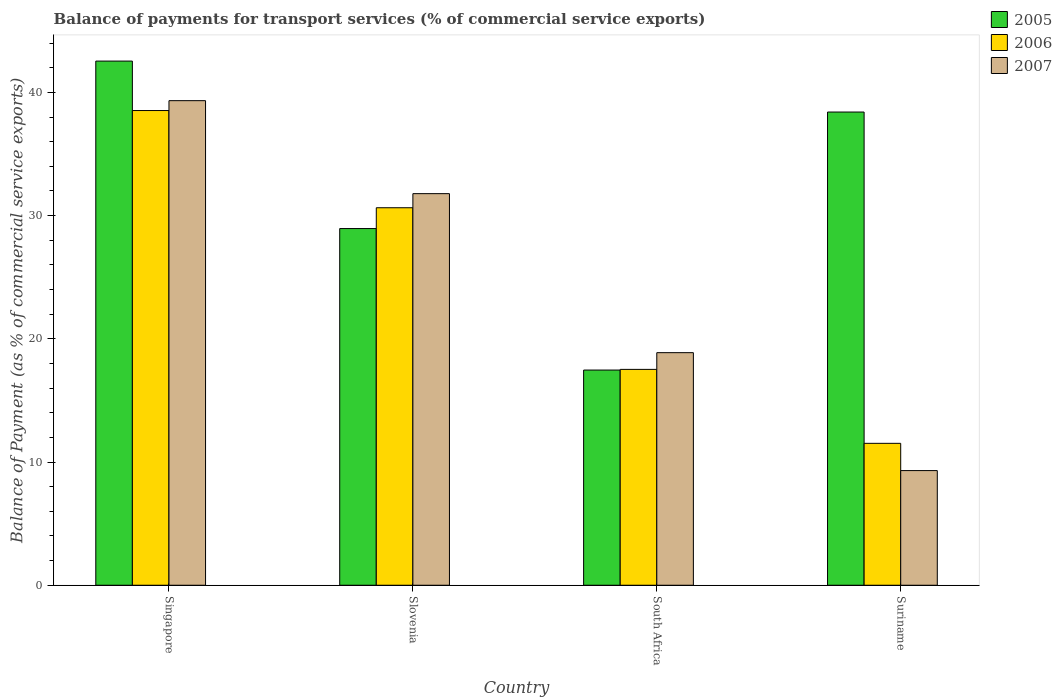How many different coloured bars are there?
Provide a succinct answer. 3. How many groups of bars are there?
Your answer should be very brief. 4. How many bars are there on the 1st tick from the left?
Your response must be concise. 3. What is the label of the 3rd group of bars from the left?
Provide a succinct answer. South Africa. What is the balance of payments for transport services in 2007 in Suriname?
Your answer should be very brief. 9.3. Across all countries, what is the maximum balance of payments for transport services in 2006?
Offer a terse response. 38.53. Across all countries, what is the minimum balance of payments for transport services in 2007?
Offer a terse response. 9.3. In which country was the balance of payments for transport services in 2005 maximum?
Ensure brevity in your answer.  Singapore. In which country was the balance of payments for transport services in 2005 minimum?
Your response must be concise. South Africa. What is the total balance of payments for transport services in 2007 in the graph?
Offer a very short reply. 99.29. What is the difference between the balance of payments for transport services in 2006 in Singapore and that in South Africa?
Give a very brief answer. 21.01. What is the difference between the balance of payments for transport services in 2006 in South Africa and the balance of payments for transport services in 2005 in Slovenia?
Your answer should be compact. -11.43. What is the average balance of payments for transport services in 2005 per country?
Your answer should be compact. 31.84. What is the difference between the balance of payments for transport services of/in 2006 and balance of payments for transport services of/in 2007 in Slovenia?
Your answer should be very brief. -1.14. What is the ratio of the balance of payments for transport services in 2006 in Singapore to that in Slovenia?
Provide a succinct answer. 1.26. Is the balance of payments for transport services in 2007 in Slovenia less than that in South Africa?
Ensure brevity in your answer.  No. What is the difference between the highest and the second highest balance of payments for transport services in 2006?
Make the answer very short. -21.01. What is the difference between the highest and the lowest balance of payments for transport services in 2005?
Provide a succinct answer. 25.08. In how many countries, is the balance of payments for transport services in 2006 greater than the average balance of payments for transport services in 2006 taken over all countries?
Your answer should be very brief. 2. What does the 1st bar from the left in Singapore represents?
Offer a terse response. 2005. What does the 3rd bar from the right in South Africa represents?
Offer a terse response. 2005. Are all the bars in the graph horizontal?
Your response must be concise. No. What is the difference between two consecutive major ticks on the Y-axis?
Provide a succinct answer. 10. Does the graph contain any zero values?
Make the answer very short. No. How many legend labels are there?
Keep it short and to the point. 3. How are the legend labels stacked?
Provide a succinct answer. Vertical. What is the title of the graph?
Provide a short and direct response. Balance of payments for transport services (% of commercial service exports). What is the label or title of the Y-axis?
Offer a terse response. Balance of Payment (as % of commercial service exports). What is the Balance of Payment (as % of commercial service exports) of 2005 in Singapore?
Provide a short and direct response. 42.54. What is the Balance of Payment (as % of commercial service exports) in 2006 in Singapore?
Keep it short and to the point. 38.53. What is the Balance of Payment (as % of commercial service exports) of 2007 in Singapore?
Your answer should be very brief. 39.33. What is the Balance of Payment (as % of commercial service exports) of 2005 in Slovenia?
Offer a terse response. 28.95. What is the Balance of Payment (as % of commercial service exports) in 2006 in Slovenia?
Offer a terse response. 30.64. What is the Balance of Payment (as % of commercial service exports) in 2007 in Slovenia?
Your response must be concise. 31.78. What is the Balance of Payment (as % of commercial service exports) in 2005 in South Africa?
Offer a very short reply. 17.47. What is the Balance of Payment (as % of commercial service exports) of 2006 in South Africa?
Offer a terse response. 17.52. What is the Balance of Payment (as % of commercial service exports) in 2007 in South Africa?
Offer a terse response. 18.88. What is the Balance of Payment (as % of commercial service exports) of 2005 in Suriname?
Your response must be concise. 38.41. What is the Balance of Payment (as % of commercial service exports) in 2006 in Suriname?
Offer a very short reply. 11.52. What is the Balance of Payment (as % of commercial service exports) of 2007 in Suriname?
Provide a succinct answer. 9.3. Across all countries, what is the maximum Balance of Payment (as % of commercial service exports) of 2005?
Your answer should be very brief. 42.54. Across all countries, what is the maximum Balance of Payment (as % of commercial service exports) of 2006?
Give a very brief answer. 38.53. Across all countries, what is the maximum Balance of Payment (as % of commercial service exports) of 2007?
Give a very brief answer. 39.33. Across all countries, what is the minimum Balance of Payment (as % of commercial service exports) of 2005?
Make the answer very short. 17.47. Across all countries, what is the minimum Balance of Payment (as % of commercial service exports) in 2006?
Keep it short and to the point. 11.52. Across all countries, what is the minimum Balance of Payment (as % of commercial service exports) of 2007?
Ensure brevity in your answer.  9.3. What is the total Balance of Payment (as % of commercial service exports) of 2005 in the graph?
Offer a terse response. 127.36. What is the total Balance of Payment (as % of commercial service exports) in 2006 in the graph?
Keep it short and to the point. 98.2. What is the total Balance of Payment (as % of commercial service exports) in 2007 in the graph?
Offer a terse response. 99.29. What is the difference between the Balance of Payment (as % of commercial service exports) in 2005 in Singapore and that in Slovenia?
Provide a succinct answer. 13.59. What is the difference between the Balance of Payment (as % of commercial service exports) in 2006 in Singapore and that in Slovenia?
Make the answer very short. 7.89. What is the difference between the Balance of Payment (as % of commercial service exports) in 2007 in Singapore and that in Slovenia?
Provide a succinct answer. 7.55. What is the difference between the Balance of Payment (as % of commercial service exports) in 2005 in Singapore and that in South Africa?
Offer a very short reply. 25.08. What is the difference between the Balance of Payment (as % of commercial service exports) in 2006 in Singapore and that in South Africa?
Ensure brevity in your answer.  21.01. What is the difference between the Balance of Payment (as % of commercial service exports) in 2007 in Singapore and that in South Africa?
Provide a short and direct response. 20.45. What is the difference between the Balance of Payment (as % of commercial service exports) of 2005 in Singapore and that in Suriname?
Your answer should be compact. 4.14. What is the difference between the Balance of Payment (as % of commercial service exports) in 2006 in Singapore and that in Suriname?
Your response must be concise. 27.01. What is the difference between the Balance of Payment (as % of commercial service exports) in 2007 in Singapore and that in Suriname?
Offer a terse response. 30.02. What is the difference between the Balance of Payment (as % of commercial service exports) in 2005 in Slovenia and that in South Africa?
Your answer should be compact. 11.48. What is the difference between the Balance of Payment (as % of commercial service exports) of 2006 in Slovenia and that in South Africa?
Offer a terse response. 13.12. What is the difference between the Balance of Payment (as % of commercial service exports) of 2007 in Slovenia and that in South Africa?
Offer a very short reply. 12.91. What is the difference between the Balance of Payment (as % of commercial service exports) of 2005 in Slovenia and that in Suriname?
Your answer should be very brief. -9.46. What is the difference between the Balance of Payment (as % of commercial service exports) in 2006 in Slovenia and that in Suriname?
Ensure brevity in your answer.  19.12. What is the difference between the Balance of Payment (as % of commercial service exports) of 2007 in Slovenia and that in Suriname?
Provide a succinct answer. 22.48. What is the difference between the Balance of Payment (as % of commercial service exports) of 2005 in South Africa and that in Suriname?
Ensure brevity in your answer.  -20.94. What is the difference between the Balance of Payment (as % of commercial service exports) in 2006 in South Africa and that in Suriname?
Offer a very short reply. 6. What is the difference between the Balance of Payment (as % of commercial service exports) in 2007 in South Africa and that in Suriname?
Ensure brevity in your answer.  9.57. What is the difference between the Balance of Payment (as % of commercial service exports) in 2005 in Singapore and the Balance of Payment (as % of commercial service exports) in 2006 in Slovenia?
Provide a succinct answer. 11.9. What is the difference between the Balance of Payment (as % of commercial service exports) in 2005 in Singapore and the Balance of Payment (as % of commercial service exports) in 2007 in Slovenia?
Provide a succinct answer. 10.76. What is the difference between the Balance of Payment (as % of commercial service exports) in 2006 in Singapore and the Balance of Payment (as % of commercial service exports) in 2007 in Slovenia?
Offer a terse response. 6.75. What is the difference between the Balance of Payment (as % of commercial service exports) of 2005 in Singapore and the Balance of Payment (as % of commercial service exports) of 2006 in South Africa?
Your answer should be very brief. 25.02. What is the difference between the Balance of Payment (as % of commercial service exports) in 2005 in Singapore and the Balance of Payment (as % of commercial service exports) in 2007 in South Africa?
Provide a short and direct response. 23.67. What is the difference between the Balance of Payment (as % of commercial service exports) in 2006 in Singapore and the Balance of Payment (as % of commercial service exports) in 2007 in South Africa?
Make the answer very short. 19.65. What is the difference between the Balance of Payment (as % of commercial service exports) in 2005 in Singapore and the Balance of Payment (as % of commercial service exports) in 2006 in Suriname?
Give a very brief answer. 31.03. What is the difference between the Balance of Payment (as % of commercial service exports) in 2005 in Singapore and the Balance of Payment (as % of commercial service exports) in 2007 in Suriname?
Provide a succinct answer. 33.24. What is the difference between the Balance of Payment (as % of commercial service exports) in 2006 in Singapore and the Balance of Payment (as % of commercial service exports) in 2007 in Suriname?
Your response must be concise. 29.22. What is the difference between the Balance of Payment (as % of commercial service exports) in 2005 in Slovenia and the Balance of Payment (as % of commercial service exports) in 2006 in South Africa?
Provide a short and direct response. 11.43. What is the difference between the Balance of Payment (as % of commercial service exports) in 2005 in Slovenia and the Balance of Payment (as % of commercial service exports) in 2007 in South Africa?
Ensure brevity in your answer.  10.07. What is the difference between the Balance of Payment (as % of commercial service exports) in 2006 in Slovenia and the Balance of Payment (as % of commercial service exports) in 2007 in South Africa?
Offer a terse response. 11.76. What is the difference between the Balance of Payment (as % of commercial service exports) in 2005 in Slovenia and the Balance of Payment (as % of commercial service exports) in 2006 in Suriname?
Offer a very short reply. 17.43. What is the difference between the Balance of Payment (as % of commercial service exports) in 2005 in Slovenia and the Balance of Payment (as % of commercial service exports) in 2007 in Suriname?
Give a very brief answer. 19.64. What is the difference between the Balance of Payment (as % of commercial service exports) in 2006 in Slovenia and the Balance of Payment (as % of commercial service exports) in 2007 in Suriname?
Make the answer very short. 21.33. What is the difference between the Balance of Payment (as % of commercial service exports) in 2005 in South Africa and the Balance of Payment (as % of commercial service exports) in 2006 in Suriname?
Your answer should be very brief. 5.95. What is the difference between the Balance of Payment (as % of commercial service exports) of 2005 in South Africa and the Balance of Payment (as % of commercial service exports) of 2007 in Suriname?
Provide a short and direct response. 8.16. What is the difference between the Balance of Payment (as % of commercial service exports) in 2006 in South Africa and the Balance of Payment (as % of commercial service exports) in 2007 in Suriname?
Make the answer very short. 8.21. What is the average Balance of Payment (as % of commercial service exports) in 2005 per country?
Offer a very short reply. 31.84. What is the average Balance of Payment (as % of commercial service exports) of 2006 per country?
Your answer should be compact. 24.55. What is the average Balance of Payment (as % of commercial service exports) in 2007 per country?
Provide a short and direct response. 24.82. What is the difference between the Balance of Payment (as % of commercial service exports) of 2005 and Balance of Payment (as % of commercial service exports) of 2006 in Singapore?
Give a very brief answer. 4.01. What is the difference between the Balance of Payment (as % of commercial service exports) in 2005 and Balance of Payment (as % of commercial service exports) in 2007 in Singapore?
Provide a short and direct response. 3.21. What is the difference between the Balance of Payment (as % of commercial service exports) in 2006 and Balance of Payment (as % of commercial service exports) in 2007 in Singapore?
Ensure brevity in your answer.  -0.8. What is the difference between the Balance of Payment (as % of commercial service exports) of 2005 and Balance of Payment (as % of commercial service exports) of 2006 in Slovenia?
Your answer should be compact. -1.69. What is the difference between the Balance of Payment (as % of commercial service exports) in 2005 and Balance of Payment (as % of commercial service exports) in 2007 in Slovenia?
Offer a terse response. -2.83. What is the difference between the Balance of Payment (as % of commercial service exports) of 2006 and Balance of Payment (as % of commercial service exports) of 2007 in Slovenia?
Offer a terse response. -1.14. What is the difference between the Balance of Payment (as % of commercial service exports) in 2005 and Balance of Payment (as % of commercial service exports) in 2006 in South Africa?
Your answer should be compact. -0.05. What is the difference between the Balance of Payment (as % of commercial service exports) of 2005 and Balance of Payment (as % of commercial service exports) of 2007 in South Africa?
Offer a very short reply. -1.41. What is the difference between the Balance of Payment (as % of commercial service exports) in 2006 and Balance of Payment (as % of commercial service exports) in 2007 in South Africa?
Your answer should be compact. -1.36. What is the difference between the Balance of Payment (as % of commercial service exports) in 2005 and Balance of Payment (as % of commercial service exports) in 2006 in Suriname?
Your answer should be very brief. 26.89. What is the difference between the Balance of Payment (as % of commercial service exports) of 2005 and Balance of Payment (as % of commercial service exports) of 2007 in Suriname?
Provide a short and direct response. 29.1. What is the difference between the Balance of Payment (as % of commercial service exports) of 2006 and Balance of Payment (as % of commercial service exports) of 2007 in Suriname?
Ensure brevity in your answer.  2.21. What is the ratio of the Balance of Payment (as % of commercial service exports) of 2005 in Singapore to that in Slovenia?
Give a very brief answer. 1.47. What is the ratio of the Balance of Payment (as % of commercial service exports) in 2006 in Singapore to that in Slovenia?
Keep it short and to the point. 1.26. What is the ratio of the Balance of Payment (as % of commercial service exports) in 2007 in Singapore to that in Slovenia?
Your answer should be very brief. 1.24. What is the ratio of the Balance of Payment (as % of commercial service exports) of 2005 in Singapore to that in South Africa?
Ensure brevity in your answer.  2.44. What is the ratio of the Balance of Payment (as % of commercial service exports) in 2006 in Singapore to that in South Africa?
Keep it short and to the point. 2.2. What is the ratio of the Balance of Payment (as % of commercial service exports) of 2007 in Singapore to that in South Africa?
Keep it short and to the point. 2.08. What is the ratio of the Balance of Payment (as % of commercial service exports) in 2005 in Singapore to that in Suriname?
Make the answer very short. 1.11. What is the ratio of the Balance of Payment (as % of commercial service exports) in 2006 in Singapore to that in Suriname?
Provide a succinct answer. 3.35. What is the ratio of the Balance of Payment (as % of commercial service exports) of 2007 in Singapore to that in Suriname?
Ensure brevity in your answer.  4.23. What is the ratio of the Balance of Payment (as % of commercial service exports) in 2005 in Slovenia to that in South Africa?
Offer a very short reply. 1.66. What is the ratio of the Balance of Payment (as % of commercial service exports) in 2006 in Slovenia to that in South Africa?
Keep it short and to the point. 1.75. What is the ratio of the Balance of Payment (as % of commercial service exports) of 2007 in Slovenia to that in South Africa?
Give a very brief answer. 1.68. What is the ratio of the Balance of Payment (as % of commercial service exports) of 2005 in Slovenia to that in Suriname?
Your response must be concise. 0.75. What is the ratio of the Balance of Payment (as % of commercial service exports) in 2006 in Slovenia to that in Suriname?
Keep it short and to the point. 2.66. What is the ratio of the Balance of Payment (as % of commercial service exports) in 2007 in Slovenia to that in Suriname?
Ensure brevity in your answer.  3.42. What is the ratio of the Balance of Payment (as % of commercial service exports) in 2005 in South Africa to that in Suriname?
Offer a very short reply. 0.45. What is the ratio of the Balance of Payment (as % of commercial service exports) of 2006 in South Africa to that in Suriname?
Ensure brevity in your answer.  1.52. What is the ratio of the Balance of Payment (as % of commercial service exports) in 2007 in South Africa to that in Suriname?
Your response must be concise. 2.03. What is the difference between the highest and the second highest Balance of Payment (as % of commercial service exports) in 2005?
Your answer should be very brief. 4.14. What is the difference between the highest and the second highest Balance of Payment (as % of commercial service exports) in 2006?
Provide a short and direct response. 7.89. What is the difference between the highest and the second highest Balance of Payment (as % of commercial service exports) of 2007?
Provide a short and direct response. 7.55. What is the difference between the highest and the lowest Balance of Payment (as % of commercial service exports) in 2005?
Your answer should be compact. 25.08. What is the difference between the highest and the lowest Balance of Payment (as % of commercial service exports) of 2006?
Ensure brevity in your answer.  27.01. What is the difference between the highest and the lowest Balance of Payment (as % of commercial service exports) in 2007?
Your answer should be compact. 30.02. 